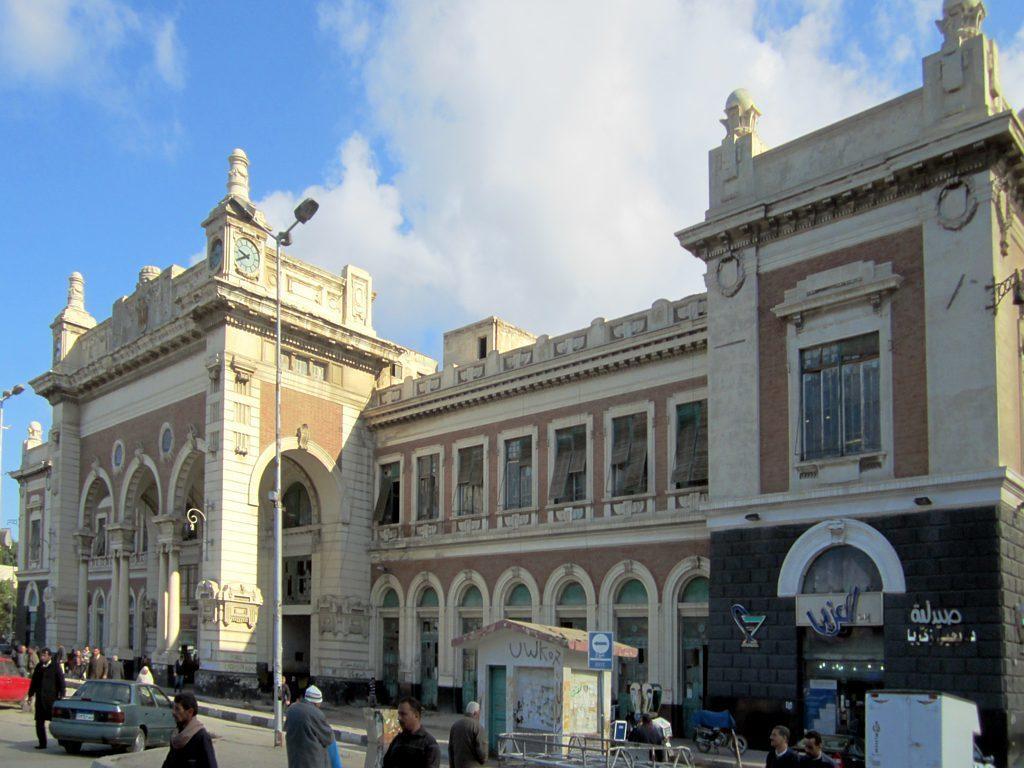Describe this image in one or two sentences. This image consists of a building along with windows and a clock. At the bottom, there is a road. On which many people are walking. And we can see a car in the middle. At the top, there are clouds in the sky. On the right, there is a small cabin. On the left, we can see the trees. 